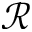<formula> <loc_0><loc_0><loc_500><loc_500>\mathcal { R }</formula> 